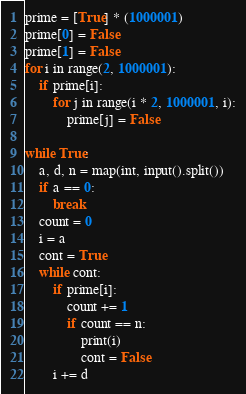Convert code to text. <code><loc_0><loc_0><loc_500><loc_500><_Python_>prime = [True] * (1000001)
prime[0] = False
prime[1] = False
for i in range(2, 1000001):
    if prime[i]:
        for j in range(i * 2, 1000001, i):
            prime[j] = False

while True:
    a, d, n = map(int, input().split())
    if a == 0:
        break
    count = 0
    i = a
    cont = True
    while cont:
        if prime[i]:
            count += 1
            if count == n:
                print(i)
                cont = False
        i += d

</code> 